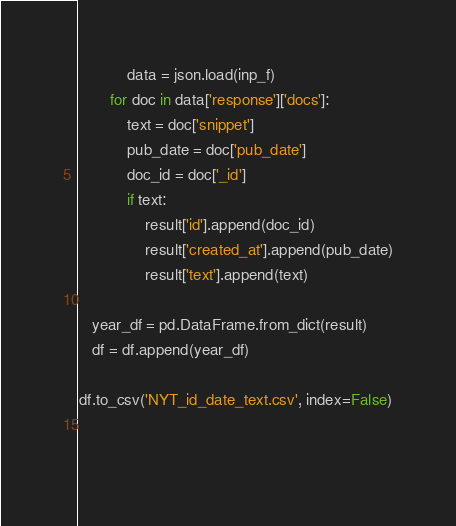<code> <loc_0><loc_0><loc_500><loc_500><_Python_>           data = json.load(inp_f)
       for doc in data['response']['docs']:
           text = doc['snippet']
           pub_date = doc['pub_date']
           doc_id = doc['_id']
           if text:
               result['id'].append(doc_id)
               result['created_at'].append(pub_date)
               result['text'].append(text)

   year_df = pd.DataFrame.from_dict(result)   
   df = df.append(year_df)

df.to_csv('NYT_id_date_text.csv', index=False)
            
            
</code> 